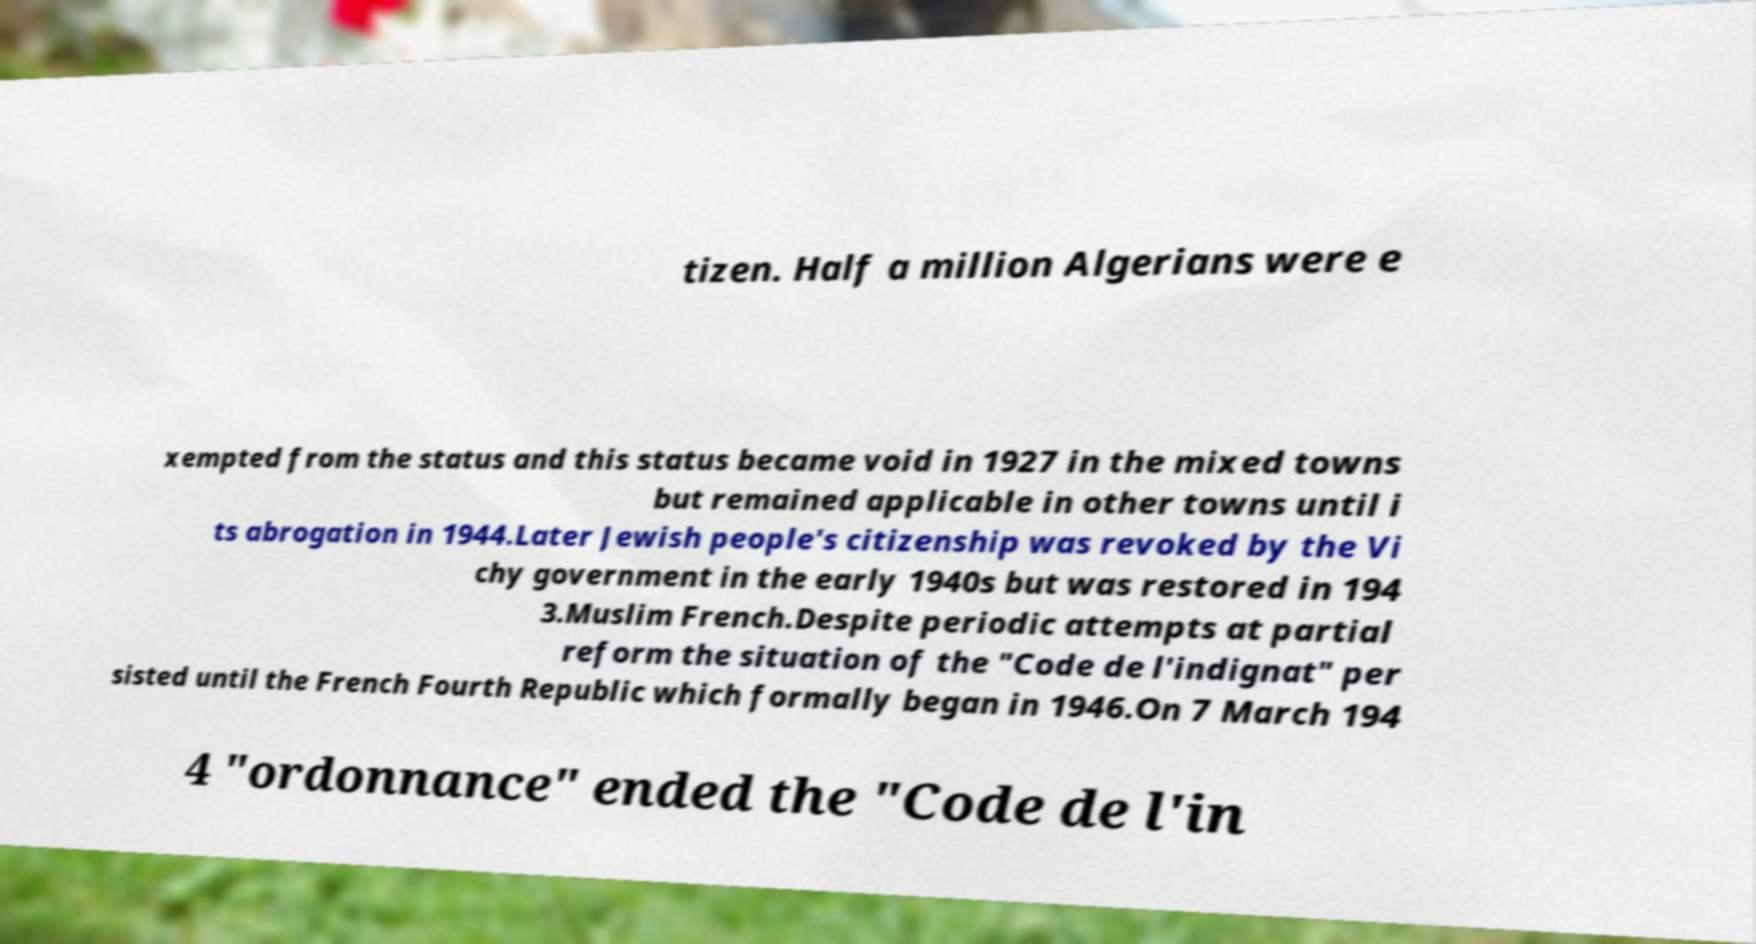There's text embedded in this image that I need extracted. Can you transcribe it verbatim? tizen. Half a million Algerians were e xempted from the status and this status became void in 1927 in the mixed towns but remained applicable in other towns until i ts abrogation in 1944.Later Jewish people's citizenship was revoked by the Vi chy government in the early 1940s but was restored in 194 3.Muslim French.Despite periodic attempts at partial reform the situation of the "Code de l'indignat" per sisted until the French Fourth Republic which formally began in 1946.On 7 March 194 4 "ordonnance" ended the "Code de l'in 